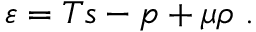Convert formula to latex. <formula><loc_0><loc_0><loc_500><loc_500>\varepsilon = T s - p + \mu \rho \ .</formula> 